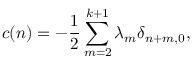<formula> <loc_0><loc_0><loc_500><loc_500>c ( n ) = - { \frac { 1 } { 2 } } \sum _ { m = 2 } ^ { k + 1 } \lambda _ { m } \delta _ { n + m , 0 } ,</formula> 